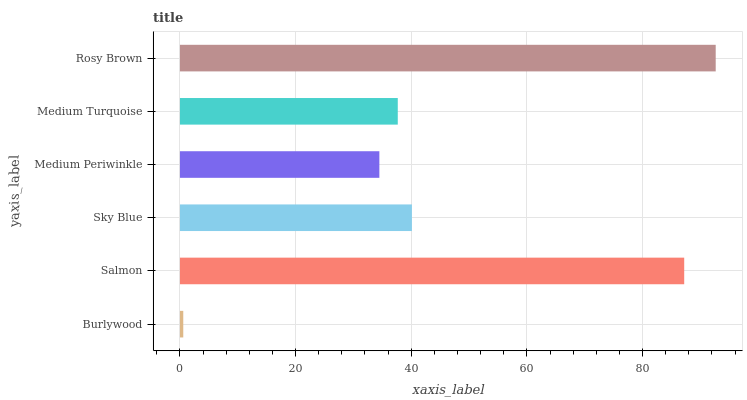Is Burlywood the minimum?
Answer yes or no. Yes. Is Rosy Brown the maximum?
Answer yes or no. Yes. Is Salmon the minimum?
Answer yes or no. No. Is Salmon the maximum?
Answer yes or no. No. Is Salmon greater than Burlywood?
Answer yes or no. Yes. Is Burlywood less than Salmon?
Answer yes or no. Yes. Is Burlywood greater than Salmon?
Answer yes or no. No. Is Salmon less than Burlywood?
Answer yes or no. No. Is Sky Blue the high median?
Answer yes or no. Yes. Is Medium Turquoise the low median?
Answer yes or no. Yes. Is Rosy Brown the high median?
Answer yes or no. No. Is Sky Blue the low median?
Answer yes or no. No. 